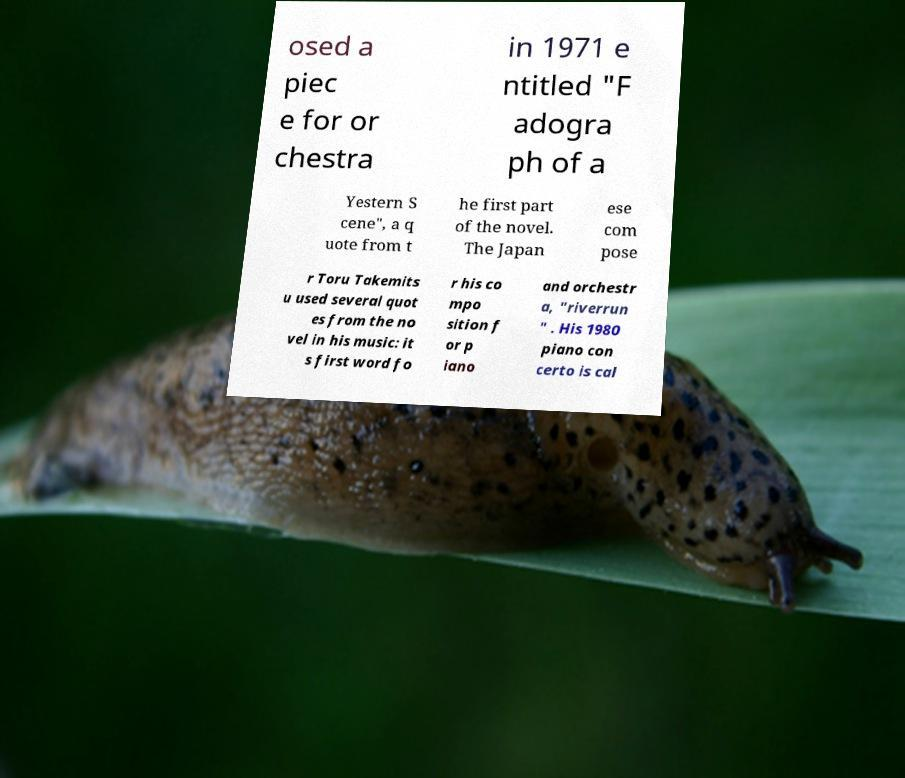Could you extract and type out the text from this image? osed a piec e for or chestra in 1971 e ntitled "F adogra ph of a Yestern S cene", a q uote from t he first part of the novel. The Japan ese com pose r Toru Takemits u used several quot es from the no vel in his music: it s first word fo r his co mpo sition f or p iano and orchestr a, "riverrun " . His 1980 piano con certo is cal 